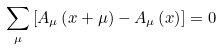<formula> <loc_0><loc_0><loc_500><loc_500>\sum _ { \mu } \left [ A _ { \mu } \left ( x + \mu \right ) - A _ { \mu } \left ( x \right ) \right ] = 0</formula> 